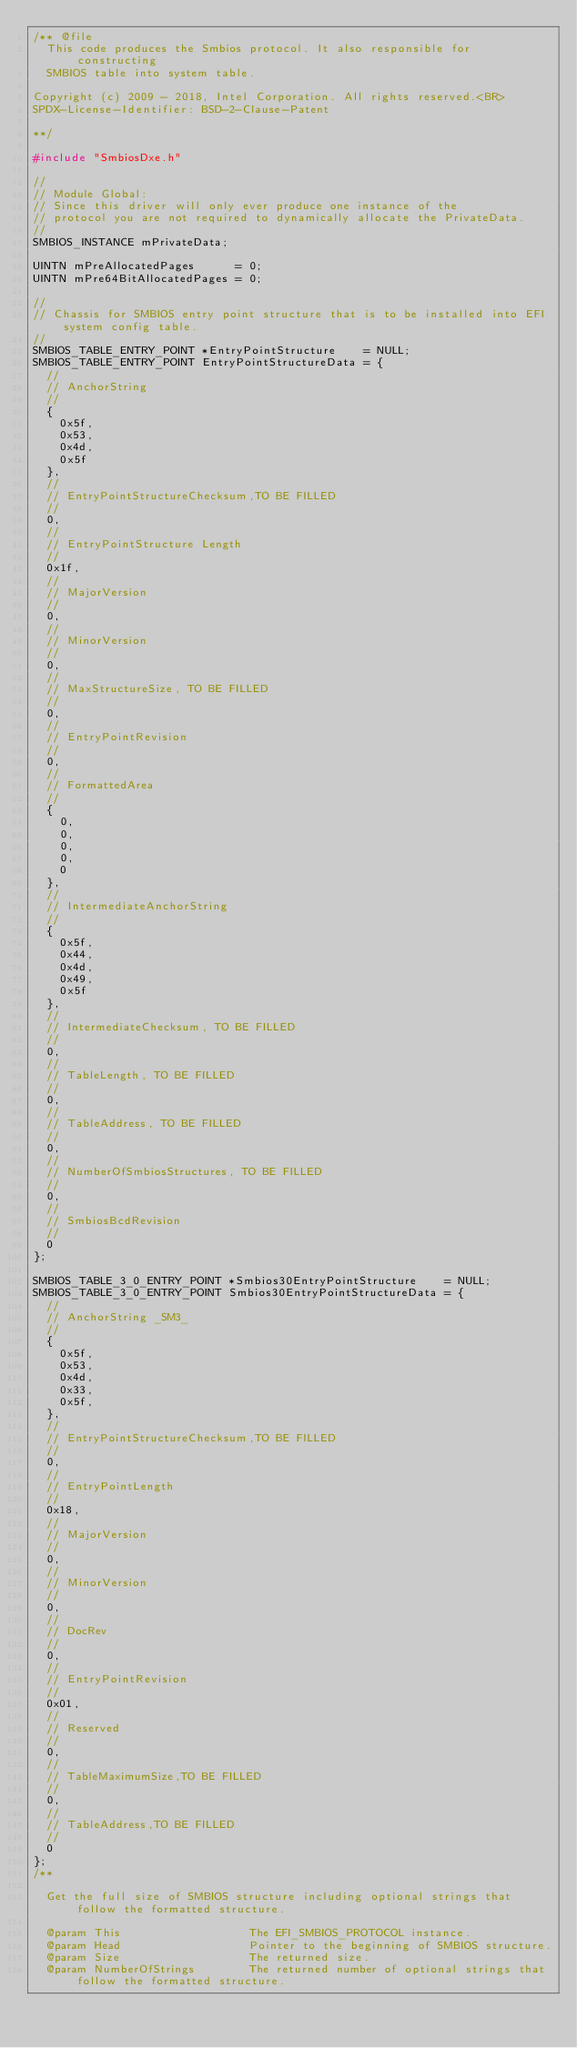Convert code to text. <code><loc_0><loc_0><loc_500><loc_500><_C_>/** @file
  This code produces the Smbios protocol. It also responsible for constructing
  SMBIOS table into system table.

Copyright (c) 2009 - 2018, Intel Corporation. All rights reserved.<BR>
SPDX-License-Identifier: BSD-2-Clause-Patent

**/

#include "SmbiosDxe.h"

//
// Module Global:
// Since this driver will only ever produce one instance of the
// protocol you are not required to dynamically allocate the PrivateData.
//
SMBIOS_INSTANCE mPrivateData;

UINTN mPreAllocatedPages      = 0;
UINTN mPre64BitAllocatedPages = 0;

//
// Chassis for SMBIOS entry point structure that is to be installed into EFI system config table.
//
SMBIOS_TABLE_ENTRY_POINT *EntryPointStructure    = NULL;
SMBIOS_TABLE_ENTRY_POINT EntryPointStructureData = {
  //
  // AnchorString
  //
  {
    0x5f,
    0x53,
    0x4d,
    0x5f
  },
  //
  // EntryPointStructureChecksum,TO BE FILLED
  //
  0,
  //
  // EntryPointStructure Length
  //
  0x1f,
  //
  // MajorVersion
  //
  0,
  //
  // MinorVersion
  //
  0,
  //
  // MaxStructureSize, TO BE FILLED
  //
  0,
  //
  // EntryPointRevision
  //
  0,
  //
  // FormattedArea
  //
  {
    0,
    0,
    0,
    0,
    0
  },
  //
  // IntermediateAnchorString
  //
  {
    0x5f,
    0x44,
    0x4d,
    0x49,
    0x5f
  },
  //
  // IntermediateChecksum, TO BE FILLED
  //
  0,
  //
  // TableLength, TO BE FILLED
  //
  0,
  //
  // TableAddress, TO BE FILLED
  //
  0,
  //
  // NumberOfSmbiosStructures, TO BE FILLED
  //
  0,
  //
  // SmbiosBcdRevision
  //
  0
};

SMBIOS_TABLE_3_0_ENTRY_POINT *Smbios30EntryPointStructure    = NULL;
SMBIOS_TABLE_3_0_ENTRY_POINT Smbios30EntryPointStructureData = {
  //
  // AnchorString _SM3_
  //
  {
    0x5f,
    0x53,
    0x4d,
    0x33,
    0x5f,
  },
  //
  // EntryPointStructureChecksum,TO BE FILLED
  //
  0,
  //
  // EntryPointLength
  //
  0x18,
  //
  // MajorVersion
  //
  0,
  //
  // MinorVersion
  //
  0,
  //
  // DocRev
  //
  0,
  //
  // EntryPointRevision
  //
  0x01,
  //
  // Reserved
  //
  0,
  //
  // TableMaximumSize,TO BE FILLED
  //
  0,
  //
  // TableAddress,TO BE FILLED
  //
  0
};
/**

  Get the full size of SMBIOS structure including optional strings that follow the formatted structure.

  @param This                   The EFI_SMBIOS_PROTOCOL instance.
  @param Head                   Pointer to the beginning of SMBIOS structure.
  @param Size                   The returned size.
  @param NumberOfStrings        The returned number of optional strings that follow the formatted structure.
</code> 